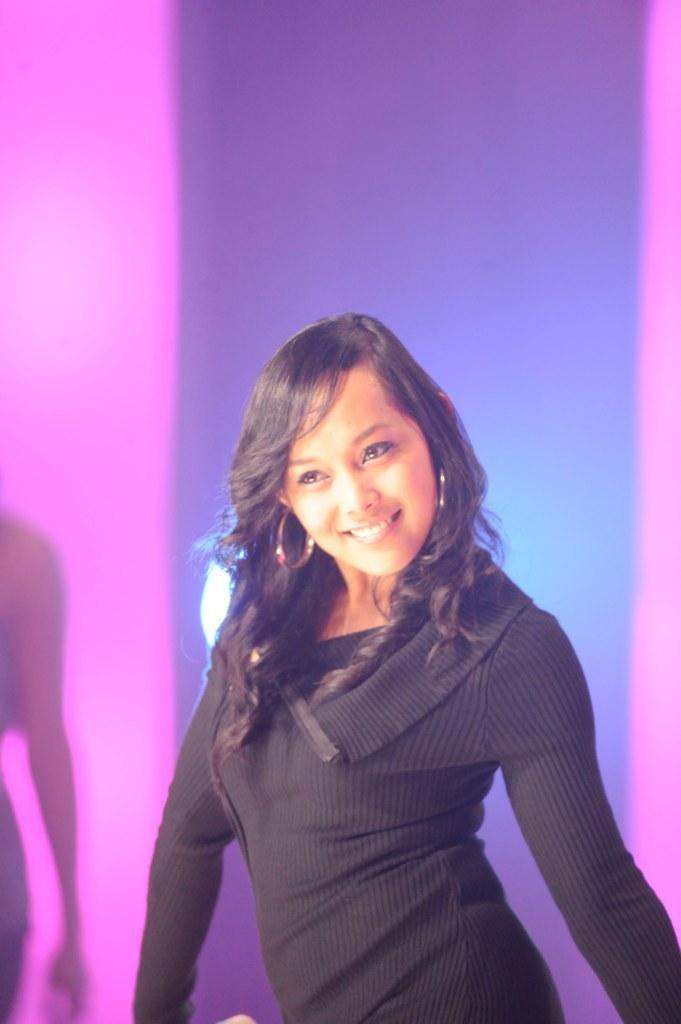Could you give a brief overview of what you see in this image? A woman is there, she wore a black color dress, she is smiling too. 